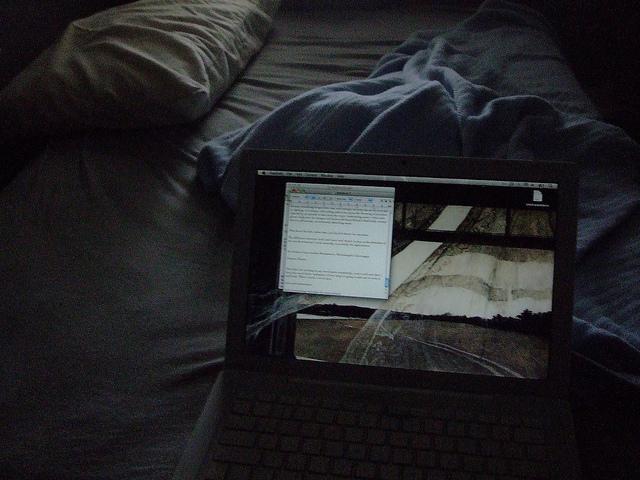What room is this?
Write a very short answer. Bedroom. Does the bed look slept in?
Concise answer only. Yes. What is on the bed?
Answer briefly. Laptop. Who is sleeping in the bed?
Short answer required. No one. Is it dark in the room?
Keep it brief. Yes. Is there a human in this image?
Short answer required. No. What color is the laptop?
Write a very short answer. Black. How old is this picture?
Concise answer only. 1 year. 